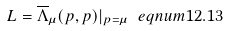Convert formula to latex. <formula><loc_0><loc_0><loc_500><loc_500>L = \overline { \Lambda } _ { \mu } ( p , p ) | _ { { p } = \mu } \ e q n u m { 1 2 . 1 3 }</formula> 